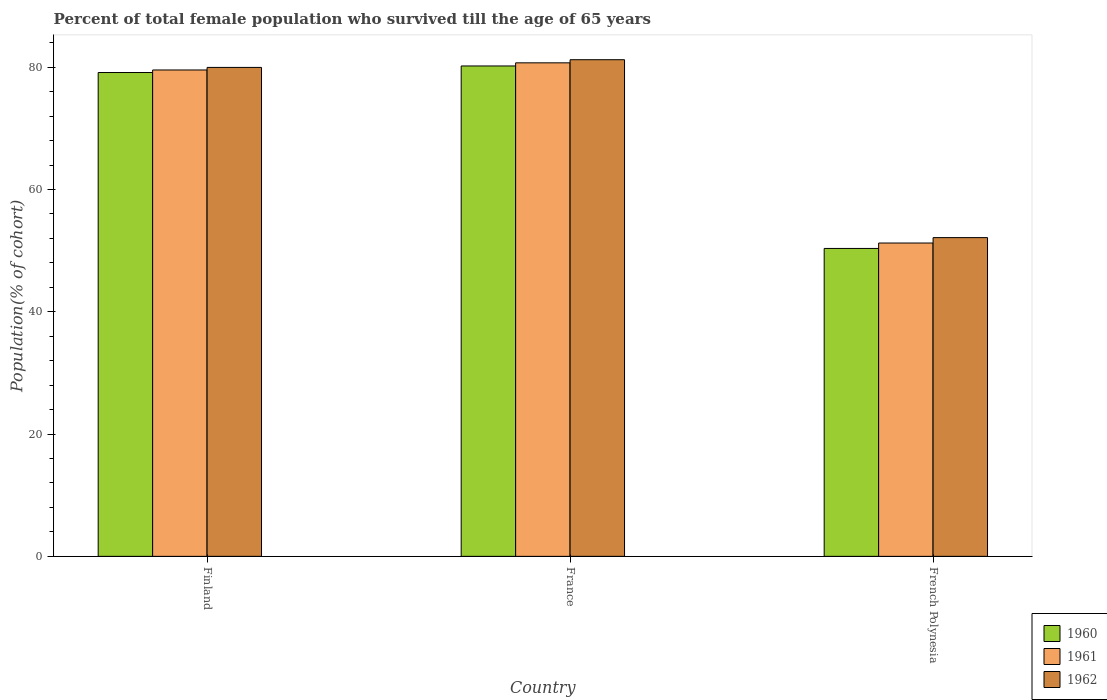How many different coloured bars are there?
Your answer should be compact. 3. Are the number of bars per tick equal to the number of legend labels?
Make the answer very short. Yes. How many bars are there on the 1st tick from the left?
Give a very brief answer. 3. What is the label of the 2nd group of bars from the left?
Make the answer very short. France. What is the percentage of total female population who survived till the age of 65 years in 1962 in Finland?
Ensure brevity in your answer.  79.97. Across all countries, what is the maximum percentage of total female population who survived till the age of 65 years in 1962?
Provide a succinct answer. 81.23. Across all countries, what is the minimum percentage of total female population who survived till the age of 65 years in 1961?
Offer a terse response. 51.25. In which country was the percentage of total female population who survived till the age of 65 years in 1962 minimum?
Offer a very short reply. French Polynesia. What is the total percentage of total female population who survived till the age of 65 years in 1961 in the graph?
Your response must be concise. 211.53. What is the difference between the percentage of total female population who survived till the age of 65 years in 1962 in France and that in French Polynesia?
Give a very brief answer. 29.1. What is the difference between the percentage of total female population who survived till the age of 65 years in 1962 in France and the percentage of total female population who survived till the age of 65 years in 1960 in French Polynesia?
Provide a short and direct response. 30.87. What is the average percentage of total female population who survived till the age of 65 years in 1961 per country?
Your answer should be compact. 70.51. What is the difference between the percentage of total female population who survived till the age of 65 years of/in 1960 and percentage of total female population who survived till the age of 65 years of/in 1962 in Finland?
Provide a short and direct response. -0.84. In how many countries, is the percentage of total female population who survived till the age of 65 years in 1962 greater than 36 %?
Ensure brevity in your answer.  3. What is the ratio of the percentage of total female population who survived till the age of 65 years in 1960 in Finland to that in French Polynesia?
Your answer should be very brief. 1.57. Is the percentage of total female population who survived till the age of 65 years in 1962 in France less than that in French Polynesia?
Provide a short and direct response. No. What is the difference between the highest and the second highest percentage of total female population who survived till the age of 65 years in 1961?
Ensure brevity in your answer.  29.47. What is the difference between the highest and the lowest percentage of total female population who survived till the age of 65 years in 1962?
Keep it short and to the point. 29.1. Is it the case that in every country, the sum of the percentage of total female population who survived till the age of 65 years in 1961 and percentage of total female population who survived till the age of 65 years in 1962 is greater than the percentage of total female population who survived till the age of 65 years in 1960?
Ensure brevity in your answer.  Yes. What is the difference between two consecutive major ticks on the Y-axis?
Make the answer very short. 20. Are the values on the major ticks of Y-axis written in scientific E-notation?
Offer a very short reply. No. Does the graph contain grids?
Your answer should be compact. No. What is the title of the graph?
Keep it short and to the point. Percent of total female population who survived till the age of 65 years. What is the label or title of the Y-axis?
Ensure brevity in your answer.  Population(% of cohort). What is the Population(% of cohort) of 1960 in Finland?
Keep it short and to the point. 79.14. What is the Population(% of cohort) of 1961 in Finland?
Keep it short and to the point. 79.56. What is the Population(% of cohort) in 1962 in Finland?
Make the answer very short. 79.97. What is the Population(% of cohort) of 1960 in France?
Your response must be concise. 80.21. What is the Population(% of cohort) in 1961 in France?
Make the answer very short. 80.72. What is the Population(% of cohort) of 1962 in France?
Your response must be concise. 81.23. What is the Population(% of cohort) of 1960 in French Polynesia?
Your answer should be very brief. 50.36. What is the Population(% of cohort) of 1961 in French Polynesia?
Make the answer very short. 51.25. What is the Population(% of cohort) of 1962 in French Polynesia?
Offer a very short reply. 52.14. Across all countries, what is the maximum Population(% of cohort) in 1960?
Your response must be concise. 80.21. Across all countries, what is the maximum Population(% of cohort) of 1961?
Provide a short and direct response. 80.72. Across all countries, what is the maximum Population(% of cohort) of 1962?
Your answer should be compact. 81.23. Across all countries, what is the minimum Population(% of cohort) in 1960?
Ensure brevity in your answer.  50.36. Across all countries, what is the minimum Population(% of cohort) in 1961?
Your answer should be very brief. 51.25. Across all countries, what is the minimum Population(% of cohort) in 1962?
Provide a short and direct response. 52.14. What is the total Population(% of cohort) of 1960 in the graph?
Your answer should be compact. 209.71. What is the total Population(% of cohort) in 1961 in the graph?
Keep it short and to the point. 211.53. What is the total Population(% of cohort) of 1962 in the graph?
Your answer should be compact. 213.34. What is the difference between the Population(% of cohort) of 1960 in Finland and that in France?
Ensure brevity in your answer.  -1.07. What is the difference between the Population(% of cohort) of 1961 in Finland and that in France?
Provide a succinct answer. -1.17. What is the difference between the Population(% of cohort) in 1962 in Finland and that in France?
Your answer should be very brief. -1.26. What is the difference between the Population(% of cohort) of 1960 in Finland and that in French Polynesia?
Give a very brief answer. 28.77. What is the difference between the Population(% of cohort) of 1961 in Finland and that in French Polynesia?
Offer a very short reply. 28.31. What is the difference between the Population(% of cohort) of 1962 in Finland and that in French Polynesia?
Provide a succinct answer. 27.84. What is the difference between the Population(% of cohort) in 1960 in France and that in French Polynesia?
Your answer should be very brief. 29.85. What is the difference between the Population(% of cohort) in 1961 in France and that in French Polynesia?
Your response must be concise. 29.47. What is the difference between the Population(% of cohort) of 1962 in France and that in French Polynesia?
Offer a terse response. 29.1. What is the difference between the Population(% of cohort) of 1960 in Finland and the Population(% of cohort) of 1961 in France?
Ensure brevity in your answer.  -1.59. What is the difference between the Population(% of cohort) of 1960 in Finland and the Population(% of cohort) of 1962 in France?
Give a very brief answer. -2.1. What is the difference between the Population(% of cohort) of 1961 in Finland and the Population(% of cohort) of 1962 in France?
Offer a terse response. -1.68. What is the difference between the Population(% of cohort) of 1960 in Finland and the Population(% of cohort) of 1961 in French Polynesia?
Offer a terse response. 27.89. What is the difference between the Population(% of cohort) of 1960 in Finland and the Population(% of cohort) of 1962 in French Polynesia?
Ensure brevity in your answer.  27. What is the difference between the Population(% of cohort) of 1961 in Finland and the Population(% of cohort) of 1962 in French Polynesia?
Offer a terse response. 27.42. What is the difference between the Population(% of cohort) in 1960 in France and the Population(% of cohort) in 1961 in French Polynesia?
Offer a terse response. 28.96. What is the difference between the Population(% of cohort) in 1960 in France and the Population(% of cohort) in 1962 in French Polynesia?
Provide a short and direct response. 28.08. What is the difference between the Population(% of cohort) of 1961 in France and the Population(% of cohort) of 1962 in French Polynesia?
Your answer should be compact. 28.59. What is the average Population(% of cohort) in 1960 per country?
Make the answer very short. 69.9. What is the average Population(% of cohort) in 1961 per country?
Your answer should be compact. 70.51. What is the average Population(% of cohort) of 1962 per country?
Your answer should be very brief. 71.11. What is the difference between the Population(% of cohort) in 1960 and Population(% of cohort) in 1961 in Finland?
Your answer should be very brief. -0.42. What is the difference between the Population(% of cohort) of 1960 and Population(% of cohort) of 1962 in Finland?
Provide a short and direct response. -0.84. What is the difference between the Population(% of cohort) in 1961 and Population(% of cohort) in 1962 in Finland?
Provide a short and direct response. -0.42. What is the difference between the Population(% of cohort) in 1960 and Population(% of cohort) in 1961 in France?
Your answer should be very brief. -0.51. What is the difference between the Population(% of cohort) of 1960 and Population(% of cohort) of 1962 in France?
Ensure brevity in your answer.  -1.02. What is the difference between the Population(% of cohort) in 1961 and Population(% of cohort) in 1962 in France?
Give a very brief answer. -0.51. What is the difference between the Population(% of cohort) in 1960 and Population(% of cohort) in 1961 in French Polynesia?
Keep it short and to the point. -0.89. What is the difference between the Population(% of cohort) of 1960 and Population(% of cohort) of 1962 in French Polynesia?
Provide a short and direct response. -1.77. What is the difference between the Population(% of cohort) of 1961 and Population(% of cohort) of 1962 in French Polynesia?
Provide a succinct answer. -0.89. What is the ratio of the Population(% of cohort) of 1960 in Finland to that in France?
Keep it short and to the point. 0.99. What is the ratio of the Population(% of cohort) of 1961 in Finland to that in France?
Your answer should be compact. 0.99. What is the ratio of the Population(% of cohort) in 1962 in Finland to that in France?
Make the answer very short. 0.98. What is the ratio of the Population(% of cohort) of 1960 in Finland to that in French Polynesia?
Make the answer very short. 1.57. What is the ratio of the Population(% of cohort) of 1961 in Finland to that in French Polynesia?
Offer a very short reply. 1.55. What is the ratio of the Population(% of cohort) of 1962 in Finland to that in French Polynesia?
Your response must be concise. 1.53. What is the ratio of the Population(% of cohort) in 1960 in France to that in French Polynesia?
Give a very brief answer. 1.59. What is the ratio of the Population(% of cohort) of 1961 in France to that in French Polynesia?
Offer a very short reply. 1.58. What is the ratio of the Population(% of cohort) of 1962 in France to that in French Polynesia?
Provide a short and direct response. 1.56. What is the difference between the highest and the second highest Population(% of cohort) of 1960?
Keep it short and to the point. 1.07. What is the difference between the highest and the second highest Population(% of cohort) in 1961?
Your answer should be compact. 1.17. What is the difference between the highest and the second highest Population(% of cohort) in 1962?
Provide a short and direct response. 1.26. What is the difference between the highest and the lowest Population(% of cohort) in 1960?
Provide a short and direct response. 29.85. What is the difference between the highest and the lowest Population(% of cohort) in 1961?
Provide a succinct answer. 29.47. What is the difference between the highest and the lowest Population(% of cohort) of 1962?
Offer a very short reply. 29.1. 